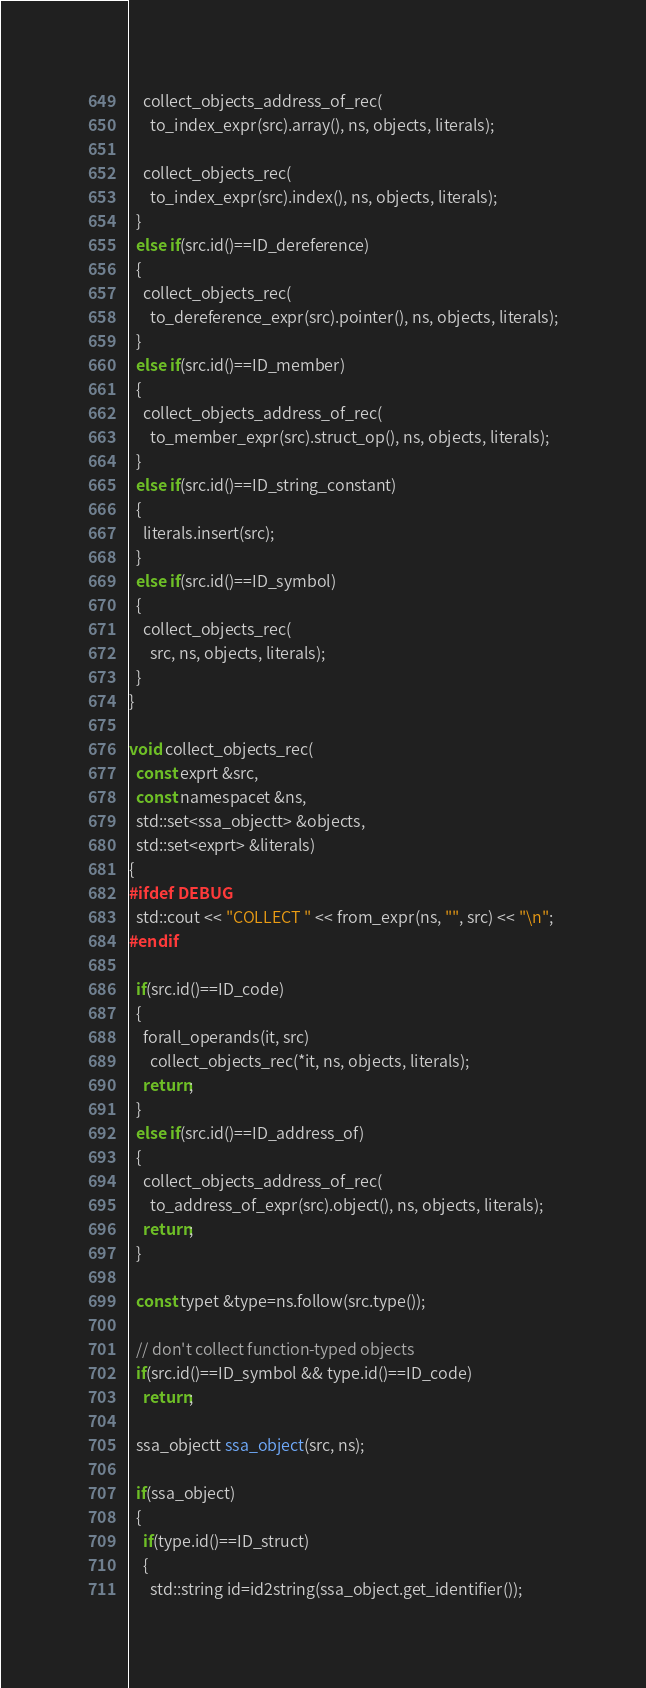Convert code to text. <code><loc_0><loc_0><loc_500><loc_500><_C++_>    collect_objects_address_of_rec(
      to_index_expr(src).array(), ns, objects, literals);

    collect_objects_rec(
      to_index_expr(src).index(), ns, objects, literals);
  }
  else if(src.id()==ID_dereference)
  {
    collect_objects_rec(
      to_dereference_expr(src).pointer(), ns, objects, literals);
  }
  else if(src.id()==ID_member)
  {
    collect_objects_address_of_rec(
      to_member_expr(src).struct_op(), ns, objects, literals);
  }
  else if(src.id()==ID_string_constant)
  {
    literals.insert(src);
  }
  else if(src.id()==ID_symbol)
  {
    collect_objects_rec(
      src, ns, objects, literals);
  }
}

void collect_objects_rec(
  const exprt &src,
  const namespacet &ns,
  std::set<ssa_objectt> &objects,
  std::set<exprt> &literals)
{
#ifdef DEBUG
  std::cout << "COLLECT " << from_expr(ns, "", src) << "\n";
#endif

  if(src.id()==ID_code)
  {
    forall_operands(it, src)
      collect_objects_rec(*it, ns, objects, literals);
    return;
  }
  else if(src.id()==ID_address_of)
  {
    collect_objects_address_of_rec(
      to_address_of_expr(src).object(), ns, objects, literals);
    return;
  }

  const typet &type=ns.follow(src.type());

  // don't collect function-typed objects
  if(src.id()==ID_symbol && type.id()==ID_code)
    return;

  ssa_objectt ssa_object(src, ns);

  if(ssa_object)
  {
    if(type.id()==ID_struct)
    {
      std::string id=id2string(ssa_object.get_identifier());</code> 